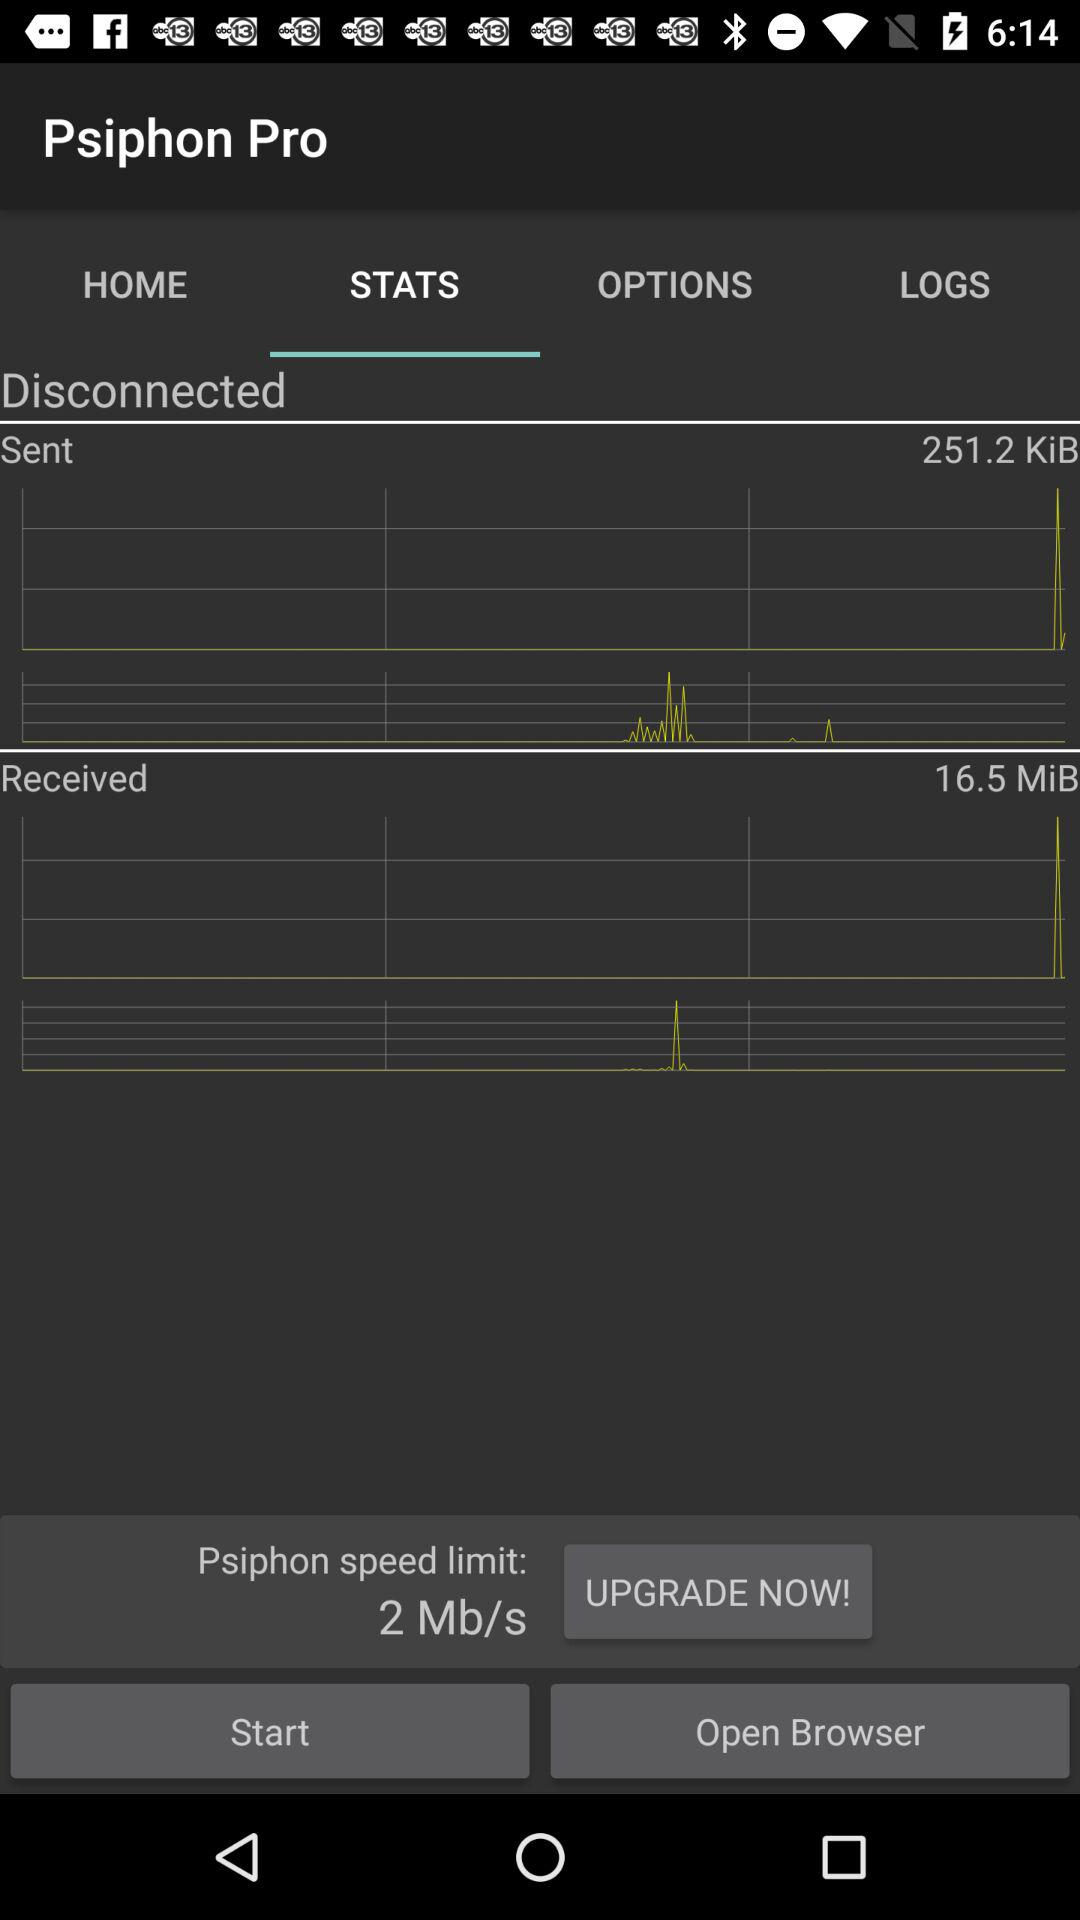How much data has been sent in KiB? The data that has been sent is 251.2 KiB. 